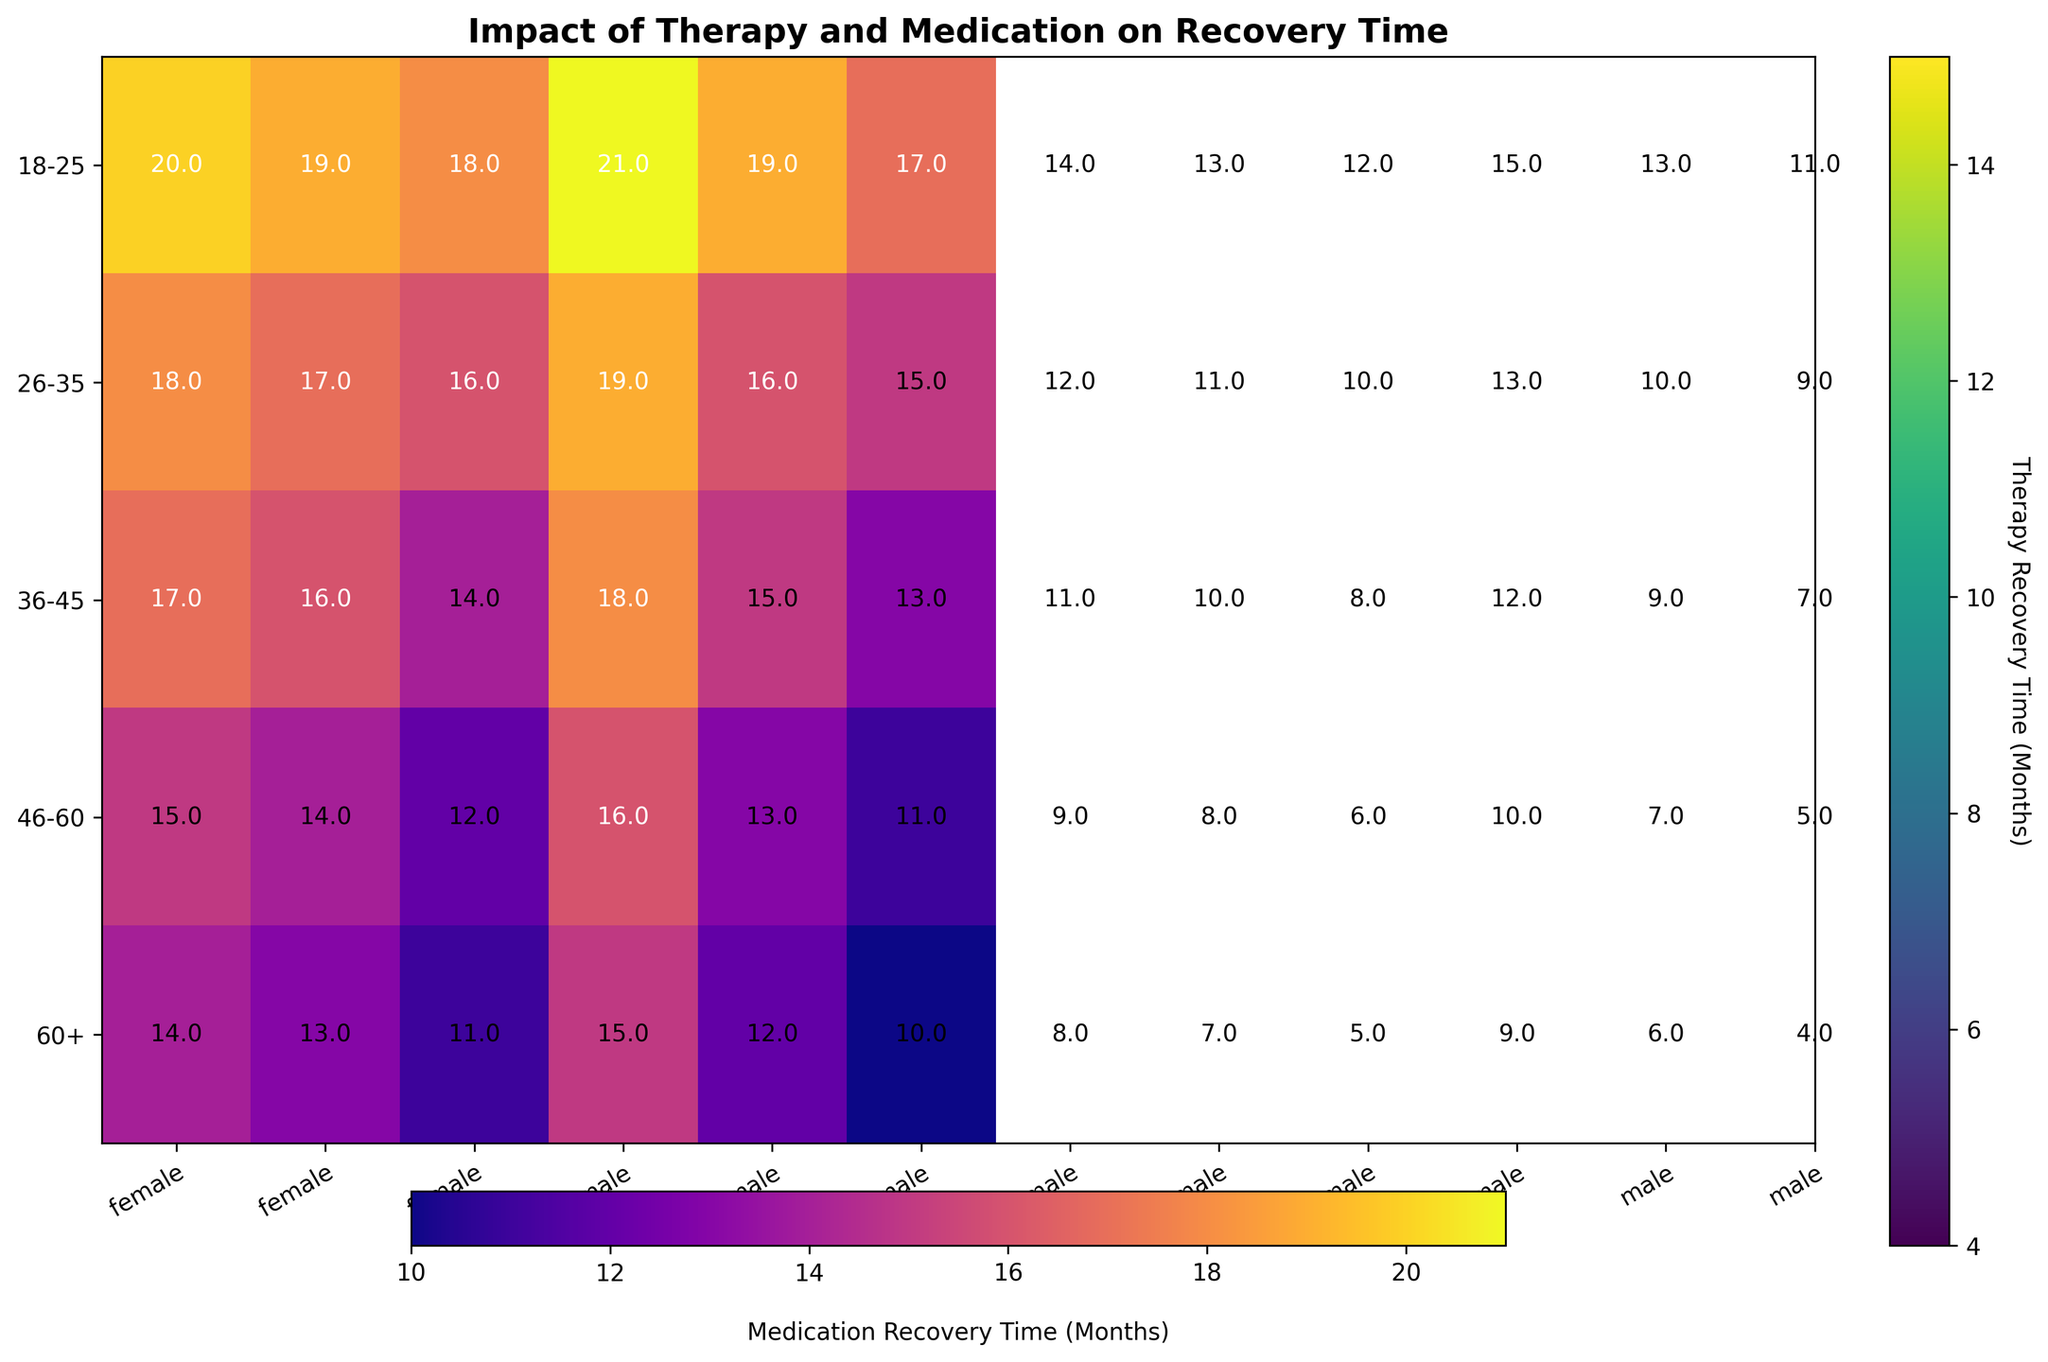Which demographic group has the shortest recovery time with therapy? To find the shortest recovery time with therapy, look for the minimum values in the 'recovery_time_with_therapy_months' section. The group '60+, male, white' has the shortest recovery time of 4 months.
Answer: 60+, male, white Which age group shows the greatest difference between recovery time with therapy and medication? To determine the greatest difference, calculate the difference between 'recovery_time_with_therapy_months' and 'recovery_time_with_medication_months' for each age group. The age group '18-25' has the widest range of differences, peaking at 6 months.
Answer: 18-25 What is the average recovery time with therapy for females aged 36-45 across all ethnicities? Look for the recovery times in the 'recovery_time_with_therapy_months' for females aged 36-45. Calculate the average of these values: (8 + 11 + 10) / 3 = 9.67 months.
Answer: 9.67 months Compare the recovery times with therapy and medication for Hispanic males aged 26-35. Which method results in shorter recovery times and by how much? Locate the recovery times: therapy (10 months) vs. medication (16 months). The recovery time with therapy is 6 months shorter (16 - 10).
Answer: Therapy by 6 months How do the recovery times with therapy for black females aged 60+ visually compare to those for white females aged 18-25? Compare the heatmap colors for '60+, female, black' (darker color indicating 8 months) and '18-25, female, white' (lighter color indicating 12 months). The color for black females aged 60+ is darker, indicating a shorter recovery time with therapy.
Answer: Black females aged 60+ have a shorter recovery time than white females aged 18-25 Identify the ethnic-gender group in the 46-60 age range with the longest recovery time using medication. Identify the darkest color (indicating longer recovery times for medication) in the '46-60' age range section. The group '46-60, male, black' has the longest recovery time of 16 months.
Answer: 46-60, male, black Calculate the difference in recovery time with therapy between white and black males aged 36-45. For therapy recovery time, white males aged 36-45 have 7 months and black males aged 36-45 have 12 months. The difference is 12 - 7 = 5 months.
Answer: 5 months Which gender shows a greater average reduction in recovery time with therapy compared to medication in the 18-25 age group? Calculate the average recovery times for males and females aged 18-25 for both therapy and medication, and then determine the reduction. Females: ((12 + 14 + 13) - (18 + 20 + 19)) / 3 = -6 months (reduction). Males: ((11 + 15 + 13) - (17 + 21 + 19)) / 3 = -7 months (reduction). Males have a greater reduction of 7 months.
Answer: Males Estimate the overall trend in recovery time with therapy as age increases across demographics. By observing the heatmap's color gradient, recovery times tend to shorten as the age increases, indicating an overall trend of faster recovery with therapy for older age groups.
Answer: Shorter recovery time as age increases 